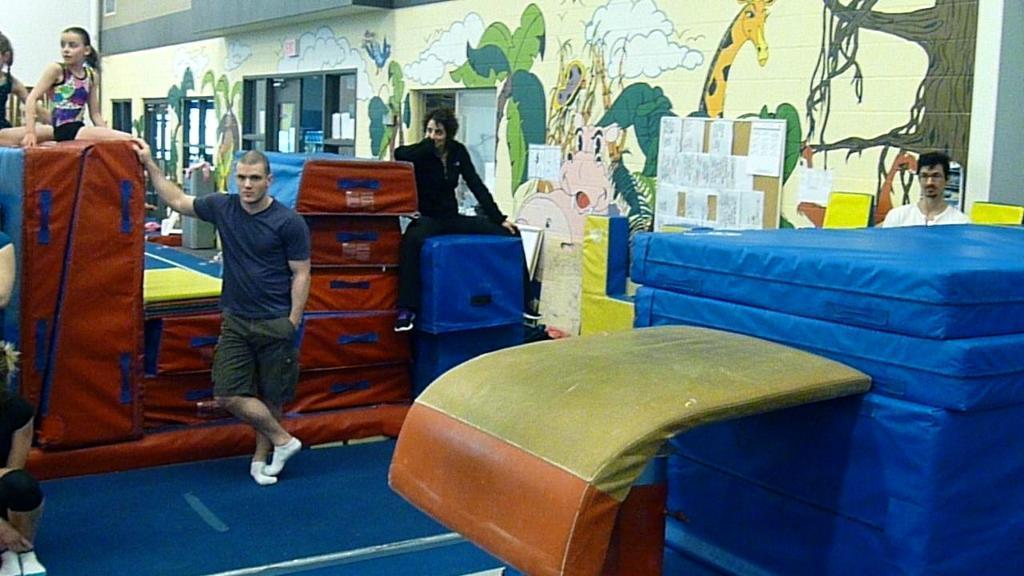Could you give a brief overview of what you see in this image? In this image we can see people, painted walls, windows and cardboard cartons. 